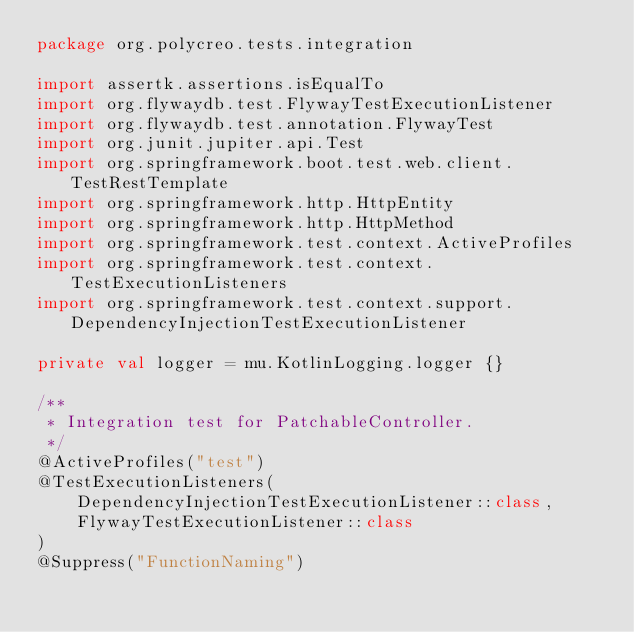Convert code to text. <code><loc_0><loc_0><loc_500><loc_500><_Kotlin_>package org.polycreo.tests.integration

import assertk.assertions.isEqualTo
import org.flywaydb.test.FlywayTestExecutionListener
import org.flywaydb.test.annotation.FlywayTest
import org.junit.jupiter.api.Test
import org.springframework.boot.test.web.client.TestRestTemplate
import org.springframework.http.HttpEntity
import org.springframework.http.HttpMethod
import org.springframework.test.context.ActiveProfiles
import org.springframework.test.context.TestExecutionListeners
import org.springframework.test.context.support.DependencyInjectionTestExecutionListener

private val logger = mu.KotlinLogging.logger {}

/**
 * Integration test for PatchableController.
 */
@ActiveProfiles("test")
@TestExecutionListeners(
    DependencyInjectionTestExecutionListener::class,
    FlywayTestExecutionListener::class
)
@Suppress("FunctionNaming")</code> 